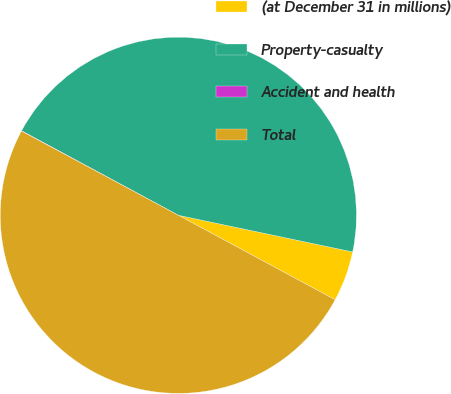<chart> <loc_0><loc_0><loc_500><loc_500><pie_chart><fcel>(at December 31 in millions)<fcel>Property-casualty<fcel>Accident and health<fcel>Total<nl><fcel>4.57%<fcel>45.43%<fcel>0.03%<fcel>49.97%<nl></chart> 